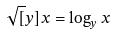Convert formula to latex. <formula><loc_0><loc_0><loc_500><loc_500>\sqrt { [ } y ] { x } = \log _ { y } x</formula> 